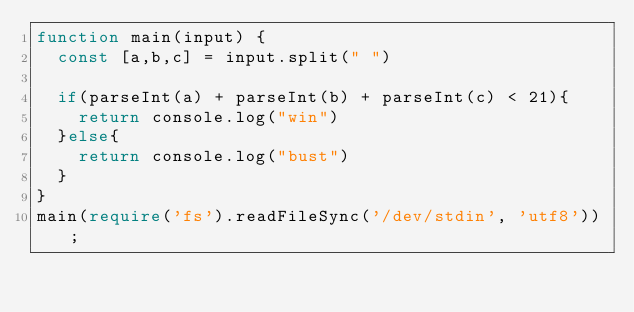<code> <loc_0><loc_0><loc_500><loc_500><_TypeScript_>function main(input) {
  const [a,b,c] = input.split(" ")
  
  if(parseInt(a) + parseInt(b) + parseInt(c) < 21){
  	return console.log("win")
  }else{
    return console.log("bust")
  }
}
main(require('fs').readFileSync('/dev/stdin', 'utf8'));</code> 